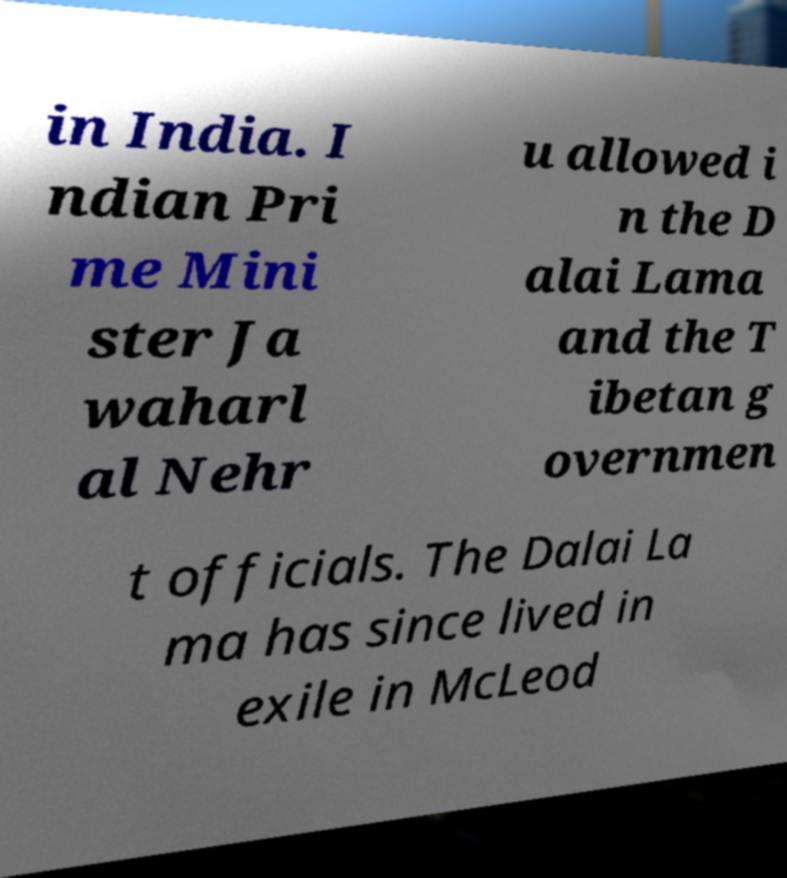What messages or text are displayed in this image? I need them in a readable, typed format. in India. I ndian Pri me Mini ster Ja waharl al Nehr u allowed i n the D alai Lama and the T ibetan g overnmen t officials. The Dalai La ma has since lived in exile in McLeod 